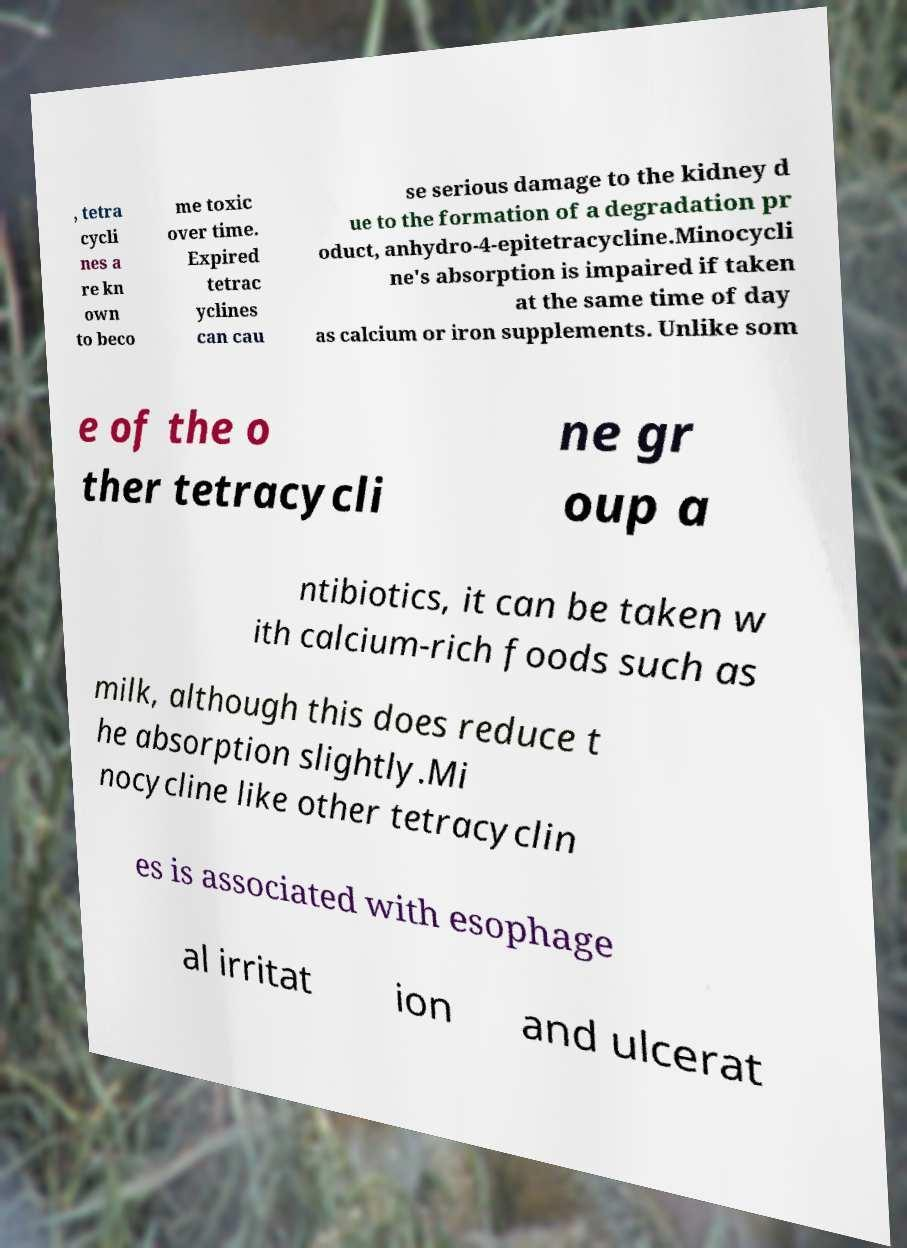Can you read and provide the text displayed in the image?This photo seems to have some interesting text. Can you extract and type it out for me? , tetra cycli nes a re kn own to beco me toxic over time. Expired tetrac yclines can cau se serious damage to the kidney d ue to the formation of a degradation pr oduct, anhydro-4-epitetracycline.Minocycli ne's absorption is impaired if taken at the same time of day as calcium or iron supplements. Unlike som e of the o ther tetracycli ne gr oup a ntibiotics, it can be taken w ith calcium-rich foods such as milk, although this does reduce t he absorption slightly.Mi nocycline like other tetracyclin es is associated with esophage al irritat ion and ulcerat 